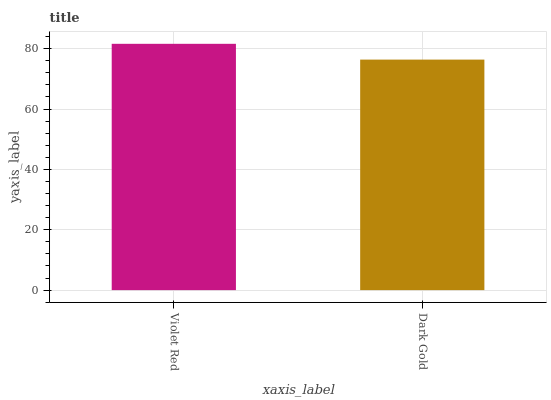Is Dark Gold the minimum?
Answer yes or no. Yes. Is Violet Red the maximum?
Answer yes or no. Yes. Is Dark Gold the maximum?
Answer yes or no. No. Is Violet Red greater than Dark Gold?
Answer yes or no. Yes. Is Dark Gold less than Violet Red?
Answer yes or no. Yes. Is Dark Gold greater than Violet Red?
Answer yes or no. No. Is Violet Red less than Dark Gold?
Answer yes or no. No. Is Violet Red the high median?
Answer yes or no. Yes. Is Dark Gold the low median?
Answer yes or no. Yes. Is Dark Gold the high median?
Answer yes or no. No. Is Violet Red the low median?
Answer yes or no. No. 